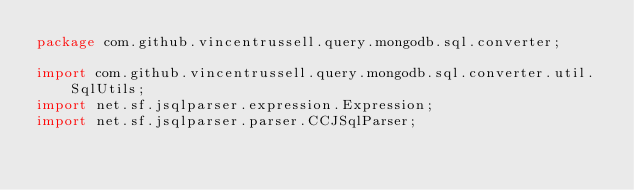<code> <loc_0><loc_0><loc_500><loc_500><_Java_>package com.github.vincentrussell.query.mongodb.sql.converter;

import com.github.vincentrussell.query.mongodb.sql.converter.util.SqlUtils;
import net.sf.jsqlparser.expression.Expression;
import net.sf.jsqlparser.parser.CCJSqlParser;</code> 